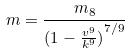Convert formula to latex. <formula><loc_0><loc_0><loc_500><loc_500>m = \frac { m _ { 8 } } { ( { 1 - \frac { v ^ { 9 } } { k ^ { 9 } } ) } ^ { 7 / 9 } }</formula> 